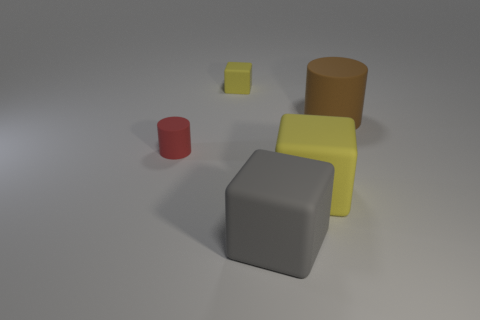Is the shape of the tiny yellow rubber thing the same as the gray matte thing?
Your answer should be very brief. Yes. What is the size of the other object that is the same shape as the big brown thing?
Your answer should be very brief. Small. Is there a matte thing of the same size as the red cylinder?
Provide a succinct answer. Yes. What material is the brown thing that is the same shape as the red rubber object?
Make the answer very short. Rubber. What is the shape of the yellow matte thing that is the same size as the gray thing?
Provide a short and direct response. Cube. Are there any green objects of the same shape as the gray matte thing?
Make the answer very short. No. There is a tiny object that is to the left of the small rubber thing behind the small red matte object; what shape is it?
Give a very brief answer. Cylinder. What is the shape of the big brown matte object?
Provide a short and direct response. Cylinder. There is a cylinder that is on the right side of the yellow block that is in front of the block that is behind the brown rubber thing; what is its material?
Your response must be concise. Rubber. What number of other objects are the same material as the small cylinder?
Offer a terse response. 4. 